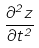Convert formula to latex. <formula><loc_0><loc_0><loc_500><loc_500>\frac { \partial ^ { 2 } z } { \partial t ^ { 2 } }</formula> 